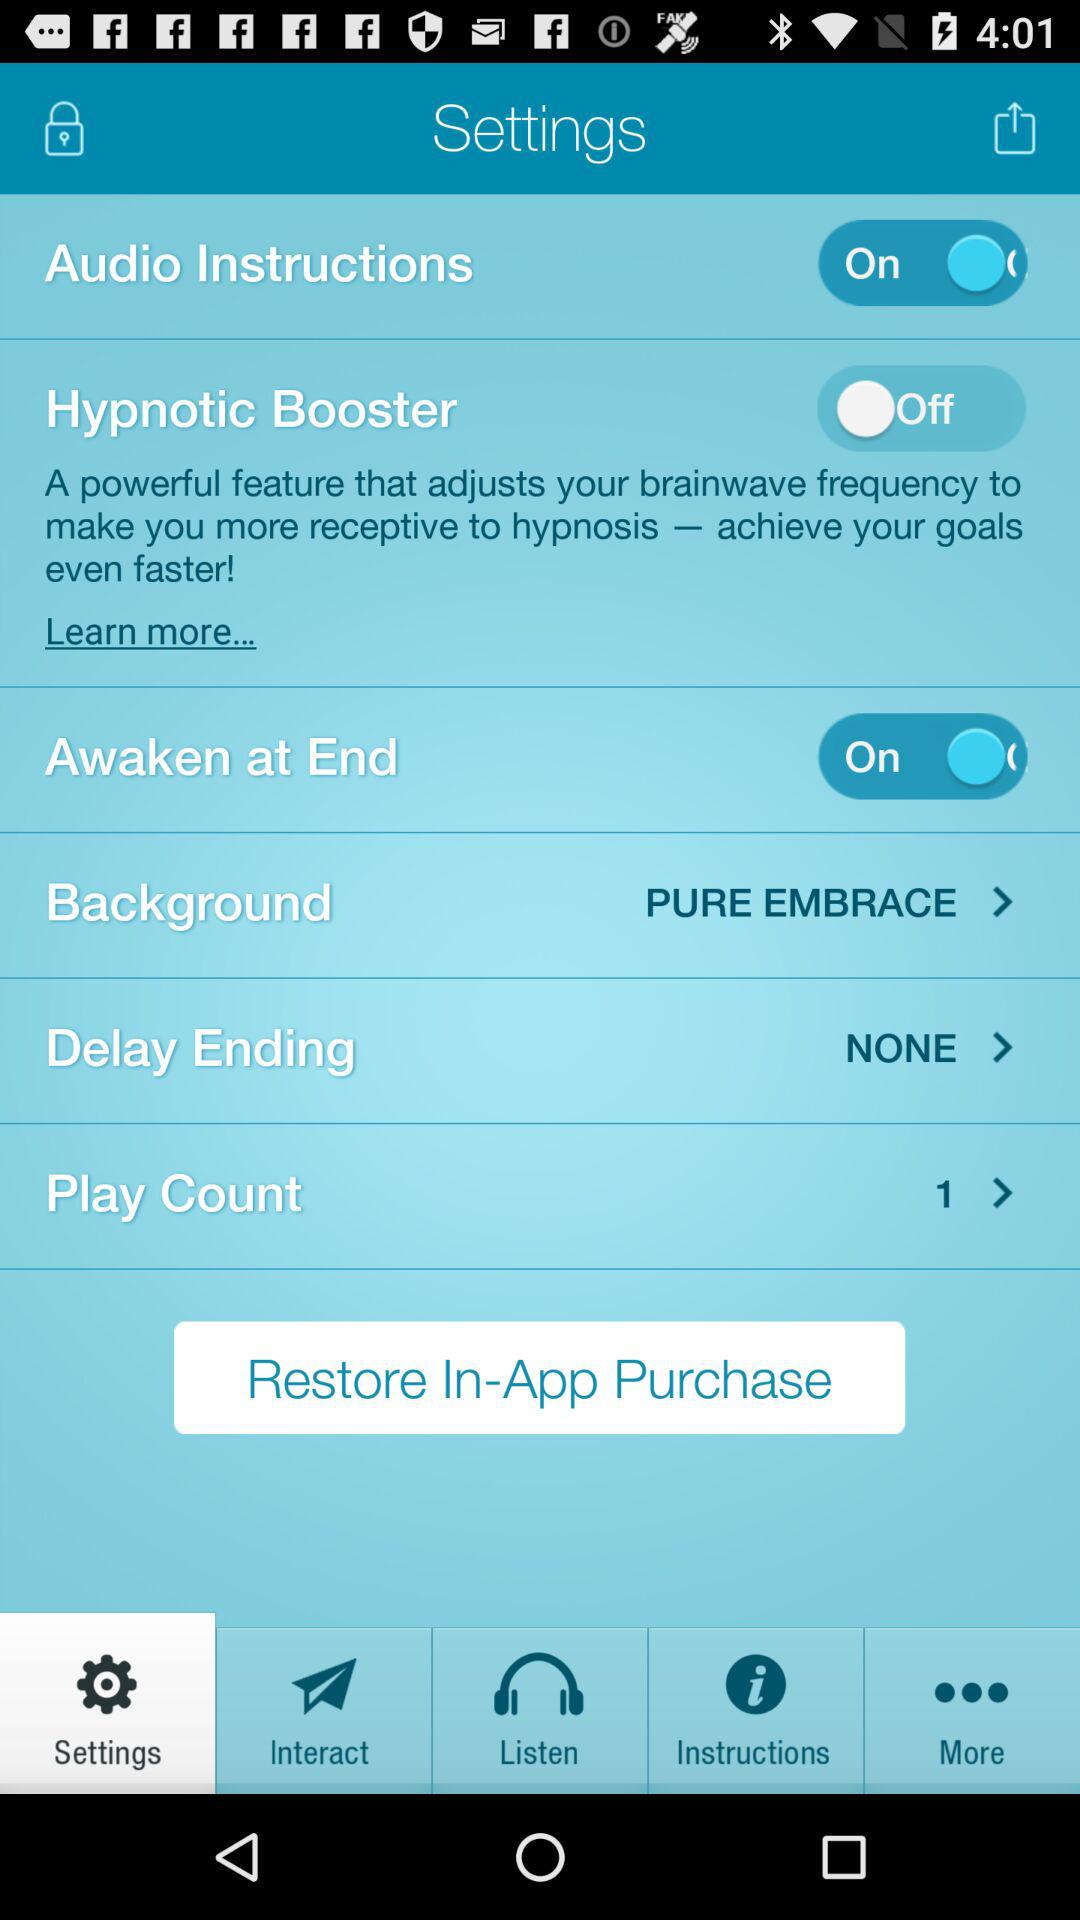Which tab has been selected? The selected tab is "Settings". 